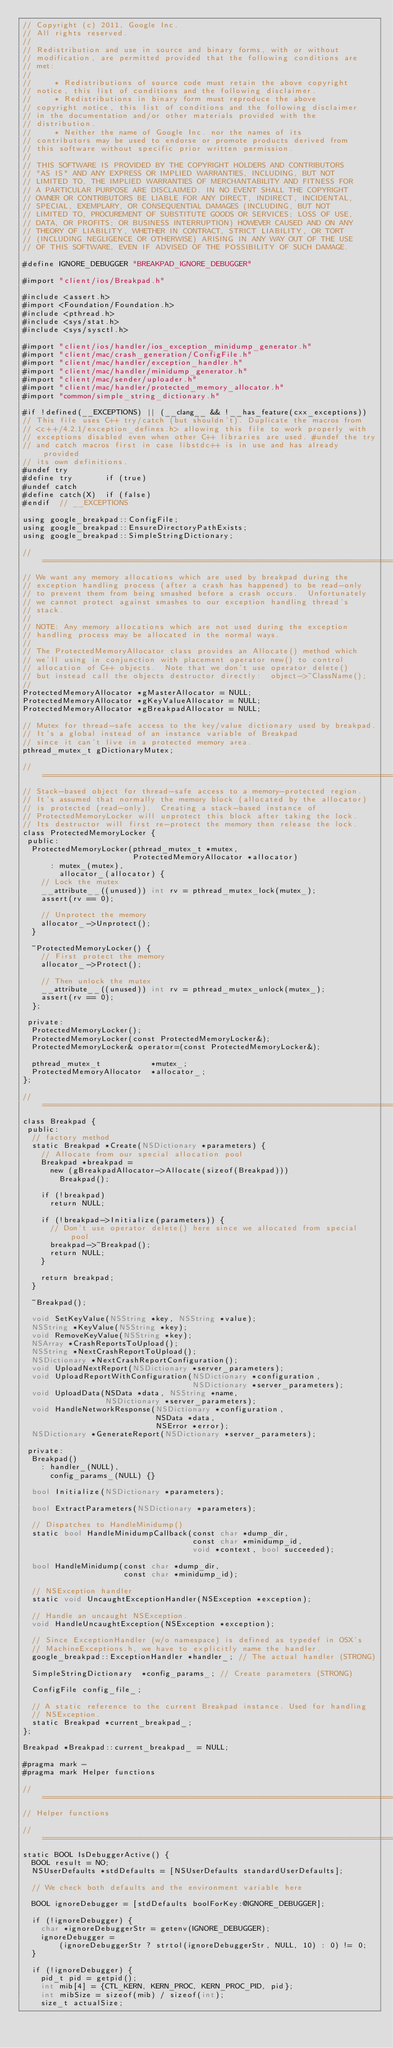Convert code to text. <code><loc_0><loc_0><loc_500><loc_500><_ObjectiveC_>// Copyright (c) 2011, Google Inc.
// All rights reserved.
//
// Redistribution and use in source and binary forms, with or without
// modification, are permitted provided that the following conditions are
// met:
//
//     * Redistributions of source code must retain the above copyright
// notice, this list of conditions and the following disclaimer.
//     * Redistributions in binary form must reproduce the above
// copyright notice, this list of conditions and the following disclaimer
// in the documentation and/or other materials provided with the
// distribution.
//     * Neither the name of Google Inc. nor the names of its
// contributors may be used to endorse or promote products derived from
// this software without specific prior written permission.
//
// THIS SOFTWARE IS PROVIDED BY THE COPYRIGHT HOLDERS AND CONTRIBUTORS
// "AS IS" AND ANY EXPRESS OR IMPLIED WARRANTIES, INCLUDING, BUT NOT
// LIMITED TO, THE IMPLIED WARRANTIES OF MERCHANTABILITY AND FITNESS FOR
// A PARTICULAR PURPOSE ARE DISCLAIMED. IN NO EVENT SHALL THE COPYRIGHT
// OWNER OR CONTRIBUTORS BE LIABLE FOR ANY DIRECT, INDIRECT, INCIDENTAL,
// SPECIAL, EXEMPLARY, OR CONSEQUENTIAL DAMAGES (INCLUDING, BUT NOT
// LIMITED TO, PROCUREMENT OF SUBSTITUTE GOODS OR SERVICES; LOSS OF USE,
// DATA, OR PROFITS; OR BUSINESS INTERRUPTION) HOWEVER CAUSED AND ON ANY
// THEORY OF LIABILITY, WHETHER IN CONTRACT, STRICT LIABILITY, OR TORT
// (INCLUDING NEGLIGENCE OR OTHERWISE) ARISING IN ANY WAY OUT OF THE USE
// OF THIS SOFTWARE, EVEN IF ADVISED OF THE POSSIBILITY OF SUCH DAMAGE.

#define IGNORE_DEBUGGER "BREAKPAD_IGNORE_DEBUGGER"

#import "client/ios/Breakpad.h"

#include <assert.h>
#import <Foundation/Foundation.h>
#include <pthread.h>
#include <sys/stat.h>
#include <sys/sysctl.h>

#import "client/ios/handler/ios_exception_minidump_generator.h"
#import "client/mac/crash_generation/ConfigFile.h"
#import "client/mac/handler/exception_handler.h"
#import "client/mac/handler/minidump_generator.h"
#import "client/mac/sender/uploader.h"
#import "client/mac/handler/protected_memory_allocator.h"
#import "common/simple_string_dictionary.h"

#if !defined(__EXCEPTIONS) || (__clang__ && !__has_feature(cxx_exceptions))
// This file uses C++ try/catch (but shouldn't). Duplicate the macros from
// <c++/4.2.1/exception_defines.h> allowing this file to work properly with
// exceptions disabled even when other C++ libraries are used. #undef the try
// and catch macros first in case libstdc++ is in use and has already provided
// its own definitions.
#undef try
#define try       if (true)
#undef catch
#define catch(X)  if (false)
#endif  // __EXCEPTIONS

using google_breakpad::ConfigFile;
using google_breakpad::EnsureDirectoryPathExists;
using google_breakpad::SimpleStringDictionary;

//=============================================================================
// We want any memory allocations which are used by breakpad during the
// exception handling process (after a crash has happened) to be read-only
// to prevent them from being smashed before a crash occurs.  Unfortunately
// we cannot protect against smashes to our exception handling thread's
// stack.
//
// NOTE: Any memory allocations which are not used during the exception
// handling process may be allocated in the normal ways.
//
// The ProtectedMemoryAllocator class provides an Allocate() method which
// we'll using in conjunction with placement operator new() to control
// allocation of C++ objects.  Note that we don't use operator delete()
// but instead call the objects destructor directly:  object->~ClassName();
//
ProtectedMemoryAllocator *gMasterAllocator = NULL;
ProtectedMemoryAllocator *gKeyValueAllocator = NULL;
ProtectedMemoryAllocator *gBreakpadAllocator = NULL;

// Mutex for thread-safe access to the key/value dictionary used by breakpad.
// It's a global instead of an instance variable of Breakpad
// since it can't live in a protected memory area.
pthread_mutex_t gDictionaryMutex;

//=============================================================================
// Stack-based object for thread-safe access to a memory-protected region.
// It's assumed that normally the memory block (allocated by the allocator)
// is protected (read-only).  Creating a stack-based instance of
// ProtectedMemoryLocker will unprotect this block after taking the lock.
// Its destructor will first re-protect the memory then release the lock.
class ProtectedMemoryLocker {
 public:
  ProtectedMemoryLocker(pthread_mutex_t *mutex,
                        ProtectedMemoryAllocator *allocator)
      : mutex_(mutex),
        allocator_(allocator) {
    // Lock the mutex
    __attribute__((unused)) int rv = pthread_mutex_lock(mutex_);
    assert(rv == 0);

    // Unprotect the memory
    allocator_->Unprotect();
  }

  ~ProtectedMemoryLocker() {
    // First protect the memory
    allocator_->Protect();

    // Then unlock the mutex
    __attribute__((unused)) int rv = pthread_mutex_unlock(mutex_);
    assert(rv == 0);
  };

 private:
  ProtectedMemoryLocker();
  ProtectedMemoryLocker(const ProtectedMemoryLocker&);
  ProtectedMemoryLocker& operator=(const ProtectedMemoryLocker&);

  pthread_mutex_t           *mutex_;
  ProtectedMemoryAllocator  *allocator_;
};

//=============================================================================
class Breakpad {
 public:
  // factory method
  static Breakpad *Create(NSDictionary *parameters) {
    // Allocate from our special allocation pool
    Breakpad *breakpad =
      new (gBreakpadAllocator->Allocate(sizeof(Breakpad)))
        Breakpad();

    if (!breakpad)
      return NULL;

    if (!breakpad->Initialize(parameters)) {
      // Don't use operator delete() here since we allocated from special pool
      breakpad->~Breakpad();
      return NULL;
    }

    return breakpad;
  }

  ~Breakpad();

  void SetKeyValue(NSString *key, NSString *value);
  NSString *KeyValue(NSString *key);
  void RemoveKeyValue(NSString *key);
  NSArray *CrashReportsToUpload();
  NSString *NextCrashReportToUpload();
  NSDictionary *NextCrashReportConfiguration();
  void UploadNextReport(NSDictionary *server_parameters);
  void UploadReportWithConfiguration(NSDictionary *configuration,
                                     NSDictionary *server_parameters);
  void UploadData(NSData *data, NSString *name,
                  NSDictionary *server_parameters);
  void HandleNetworkResponse(NSDictionary *configuration,
                             NSData *data,
                             NSError *error);
  NSDictionary *GenerateReport(NSDictionary *server_parameters);

 private:
  Breakpad()
    : handler_(NULL),
      config_params_(NULL) {}

  bool Initialize(NSDictionary *parameters);

  bool ExtractParameters(NSDictionary *parameters);

  // Dispatches to HandleMinidump()
  static bool HandleMinidumpCallback(const char *dump_dir,
                                     const char *minidump_id,
                                     void *context, bool succeeded);

  bool HandleMinidump(const char *dump_dir,
                      const char *minidump_id);

  // NSException handler
  static void UncaughtExceptionHandler(NSException *exception);

  // Handle an uncaught NSException.
  void HandleUncaughtException(NSException *exception);

  // Since ExceptionHandler (w/o namespace) is defined as typedef in OSX's
  // MachineExceptions.h, we have to explicitly name the handler.
  google_breakpad::ExceptionHandler *handler_; // The actual handler (STRONG)

  SimpleStringDictionary  *config_params_; // Create parameters (STRONG)

  ConfigFile config_file_;

  // A static reference to the current Breakpad instance. Used for handling
  // NSException.
  static Breakpad *current_breakpad_;
};

Breakpad *Breakpad::current_breakpad_ = NULL;

#pragma mark -
#pragma mark Helper functions

//=============================================================================
// Helper functions

//=============================================================================
static BOOL IsDebuggerActive() {
  BOOL result = NO;
  NSUserDefaults *stdDefaults = [NSUserDefaults standardUserDefaults];

  // We check both defaults and the environment variable here

  BOOL ignoreDebugger = [stdDefaults boolForKey:@IGNORE_DEBUGGER];

  if (!ignoreDebugger) {
    char *ignoreDebuggerStr = getenv(IGNORE_DEBUGGER);
    ignoreDebugger =
        (ignoreDebuggerStr ? strtol(ignoreDebuggerStr, NULL, 10) : 0) != 0;
  }

  if (!ignoreDebugger) {
    pid_t pid = getpid();
    int mib[4] = {CTL_KERN, KERN_PROC, KERN_PROC_PID, pid};
    int mibSize = sizeof(mib) / sizeof(int);
    size_t actualSize;
</code> 